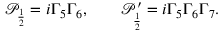Convert formula to latex. <formula><loc_0><loc_0><loc_500><loc_500>\mathcal { P } _ { \frac { 1 } { 2 } } = i \Gamma _ { 5 } \Gamma _ { 6 } , \quad \mathcal { P } _ { \frac { 1 } { 2 } } ^ { \prime } = i \Gamma _ { 5 } \Gamma _ { 6 } \Gamma _ { 7 } .</formula> 